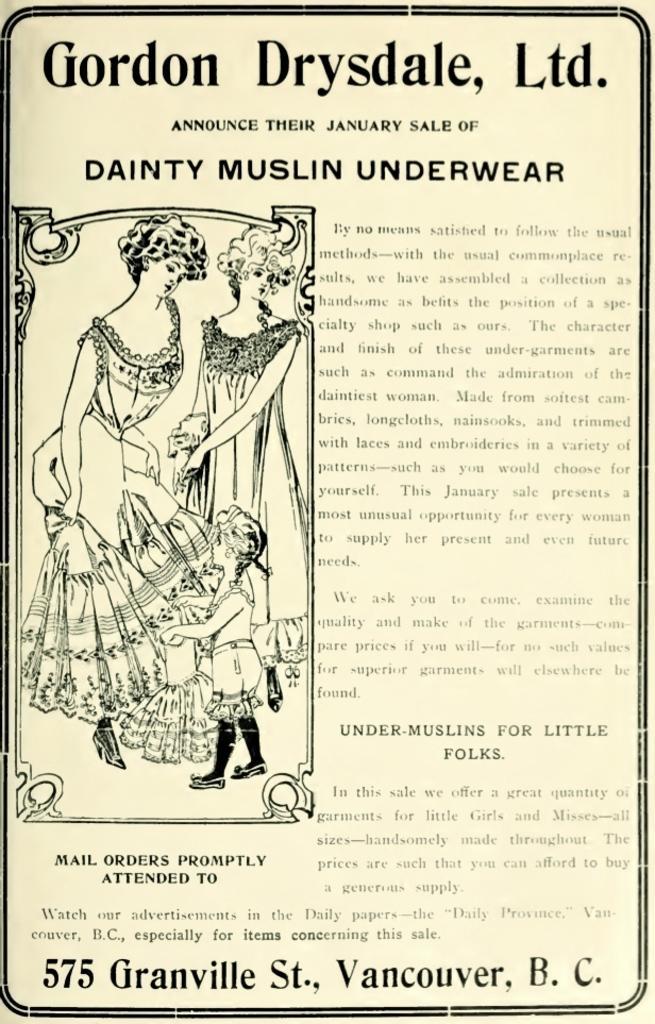Please provide a concise description of this image. In the image there is a poster. On the poster there are images of two ladies and one baby. And there is text on it. 